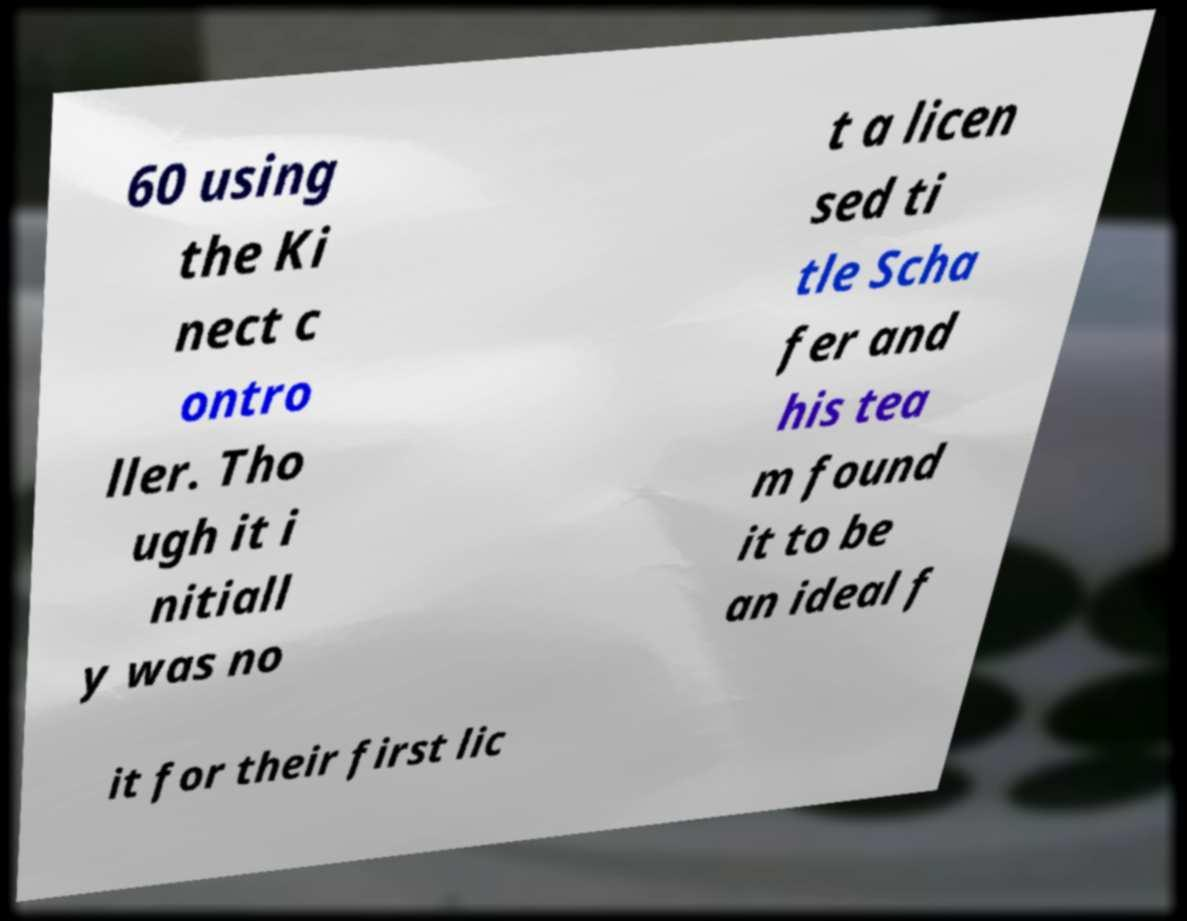Could you assist in decoding the text presented in this image and type it out clearly? 60 using the Ki nect c ontro ller. Tho ugh it i nitiall y was no t a licen sed ti tle Scha fer and his tea m found it to be an ideal f it for their first lic 